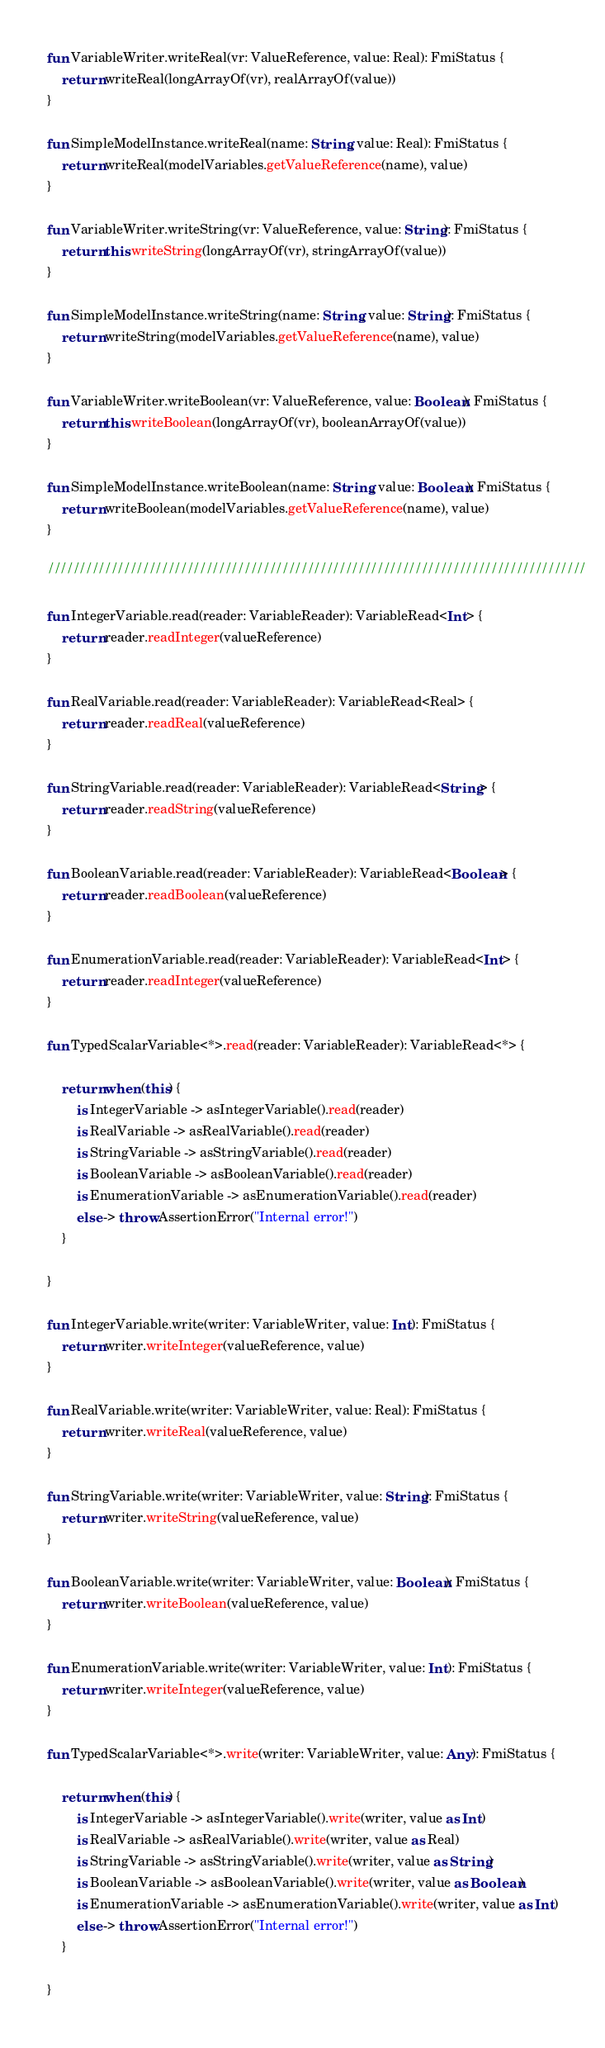Convert code to text. <code><loc_0><loc_0><loc_500><loc_500><_Kotlin_>fun VariableWriter.writeReal(vr: ValueReference, value: Real): FmiStatus {
    return writeReal(longArrayOf(vr), realArrayOf(value))
}

fun SimpleModelInstance.writeReal(name: String, value: Real): FmiStatus {
    return writeReal(modelVariables.getValueReference(name), value)
}

fun VariableWriter.writeString(vr: ValueReference, value: String): FmiStatus {
    return this.writeString(longArrayOf(vr), stringArrayOf(value))
}

fun SimpleModelInstance.writeString(name: String, value: String): FmiStatus {
    return writeString(modelVariables.getValueReference(name), value)
}

fun VariableWriter.writeBoolean(vr: ValueReference, value: Boolean): FmiStatus {
    return this.writeBoolean(longArrayOf(vr), booleanArrayOf(value))
}

fun SimpleModelInstance.writeBoolean(name: String, value: Boolean): FmiStatus {
    return writeBoolean(modelVariables.getValueReference(name), value)
}

/////////////////////////////////////////////////////////////////////////////////////

fun IntegerVariable.read(reader: VariableReader): VariableRead<Int> {
    return reader.readInteger(valueReference)
}

fun RealVariable.read(reader: VariableReader): VariableRead<Real> {
    return reader.readReal(valueReference)
}

fun StringVariable.read(reader: VariableReader): VariableRead<String> {
    return reader.readString(valueReference)
}

fun BooleanVariable.read(reader: VariableReader): VariableRead<Boolean> {
    return reader.readBoolean(valueReference)
}

fun EnumerationVariable.read(reader: VariableReader): VariableRead<Int> {
    return reader.readInteger(valueReference)
}

fun TypedScalarVariable<*>.read(reader: VariableReader): VariableRead<*> {

    return when (this) {
        is IntegerVariable -> asIntegerVariable().read(reader)
        is RealVariable -> asRealVariable().read(reader)
        is StringVariable -> asStringVariable().read(reader)
        is BooleanVariable -> asBooleanVariable().read(reader)
        is EnumerationVariable -> asEnumerationVariable().read(reader)
        else -> throw AssertionError("Internal error!")
    }

}

fun IntegerVariable.write(writer: VariableWriter, value: Int): FmiStatus {
    return writer.writeInteger(valueReference, value)
}

fun RealVariable.write(writer: VariableWriter, value: Real): FmiStatus {
    return writer.writeReal(valueReference, value)
}

fun StringVariable.write(writer: VariableWriter, value: String): FmiStatus {
    return writer.writeString(valueReference, value)
}

fun BooleanVariable.write(writer: VariableWriter, value: Boolean): FmiStatus {
    return writer.writeBoolean(valueReference, value)
}

fun EnumerationVariable.write(writer: VariableWriter, value: Int): FmiStatus {
    return writer.writeInteger(valueReference, value)
}

fun TypedScalarVariable<*>.write(writer: VariableWriter, value: Any): FmiStatus {

    return when (this) {
        is IntegerVariable -> asIntegerVariable().write(writer, value as Int)
        is RealVariable -> asRealVariable().write(writer, value as Real)
        is StringVariable -> asStringVariable().write(writer, value as String)
        is BooleanVariable -> asBooleanVariable().write(writer, value as Boolean)
        is EnumerationVariable -> asEnumerationVariable().write(writer, value as Int)
        else -> throw AssertionError("Internal error!")
    }

}
</code> 